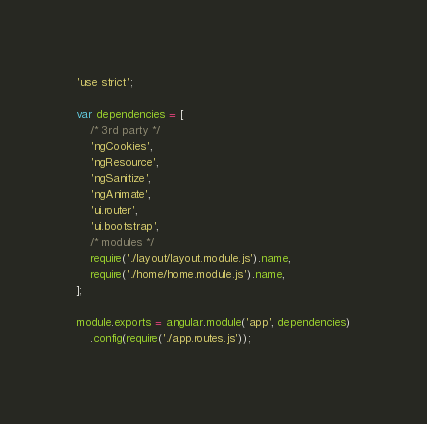<code> <loc_0><loc_0><loc_500><loc_500><_JavaScript_>'use strict';

var dependencies = [
	/* 3rd party */
	'ngCookies',
	'ngResource',
	'ngSanitize',
	'ngAnimate',
	'ui.router',
	'ui.bootstrap',
	/* modules */
	require('./layout/layout.module.js').name,
	require('./home/home.module.js').name,
];

module.exports = angular.module('app', dependencies)
	.config(require('./app.routes.js'));
</code> 